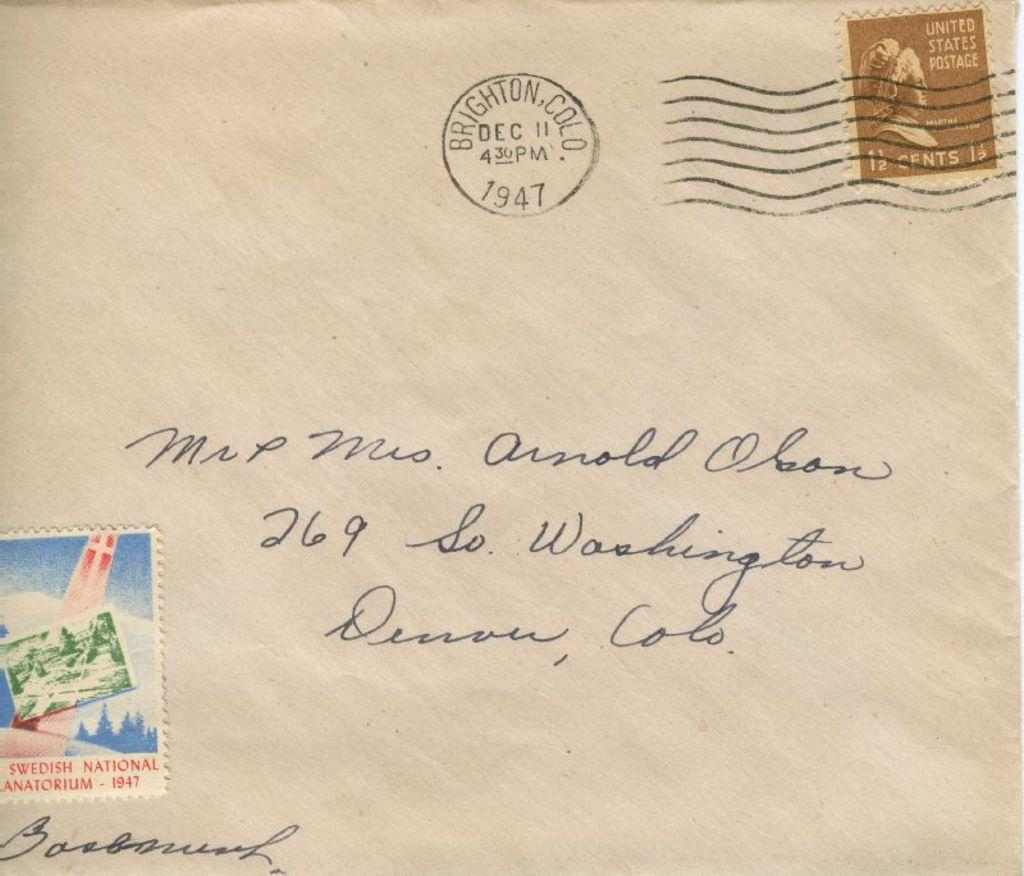<image>
Share a concise interpretation of the image provided. A letter stamped 1947 is addressed to Mr. and Mrs. Olson. 